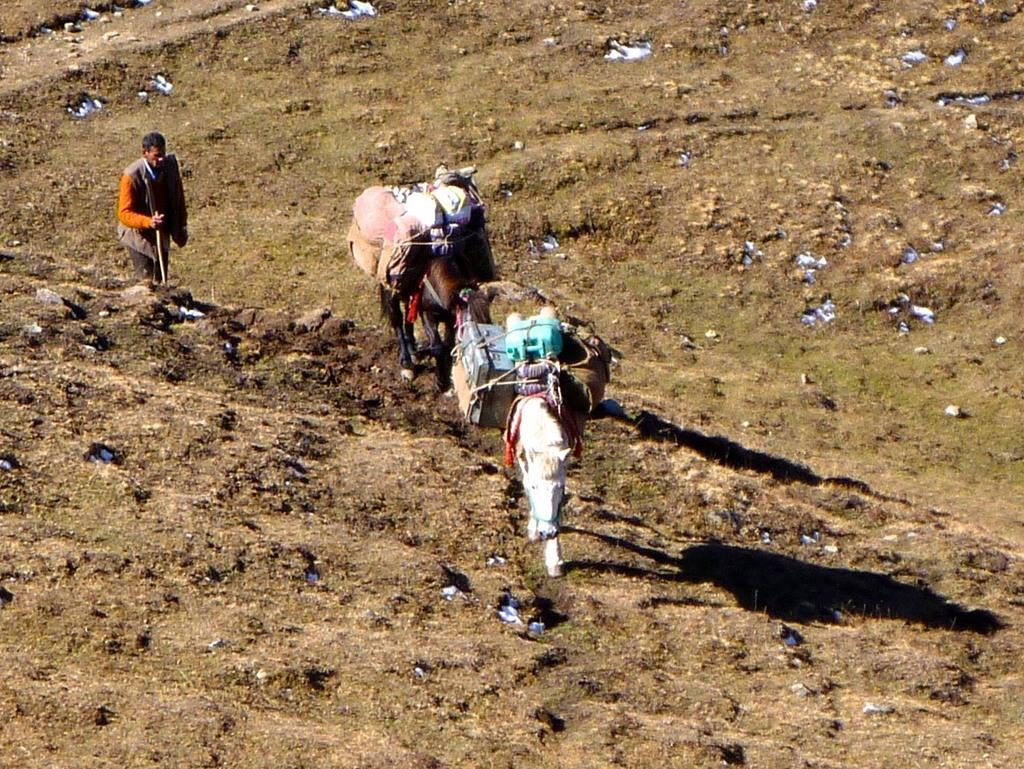What animals are present in the image? There are horses in the image. What else can be seen in the image besides the horses? There is luggage and a person in the image. What is the person holding in the image? The person is holding a stick. What type of surface is visible in the image? There is ground visible in the image. What type of chain can be seen hanging from the horses in the image? There is no chain present in the image; the horses are not depicted with any chains. 